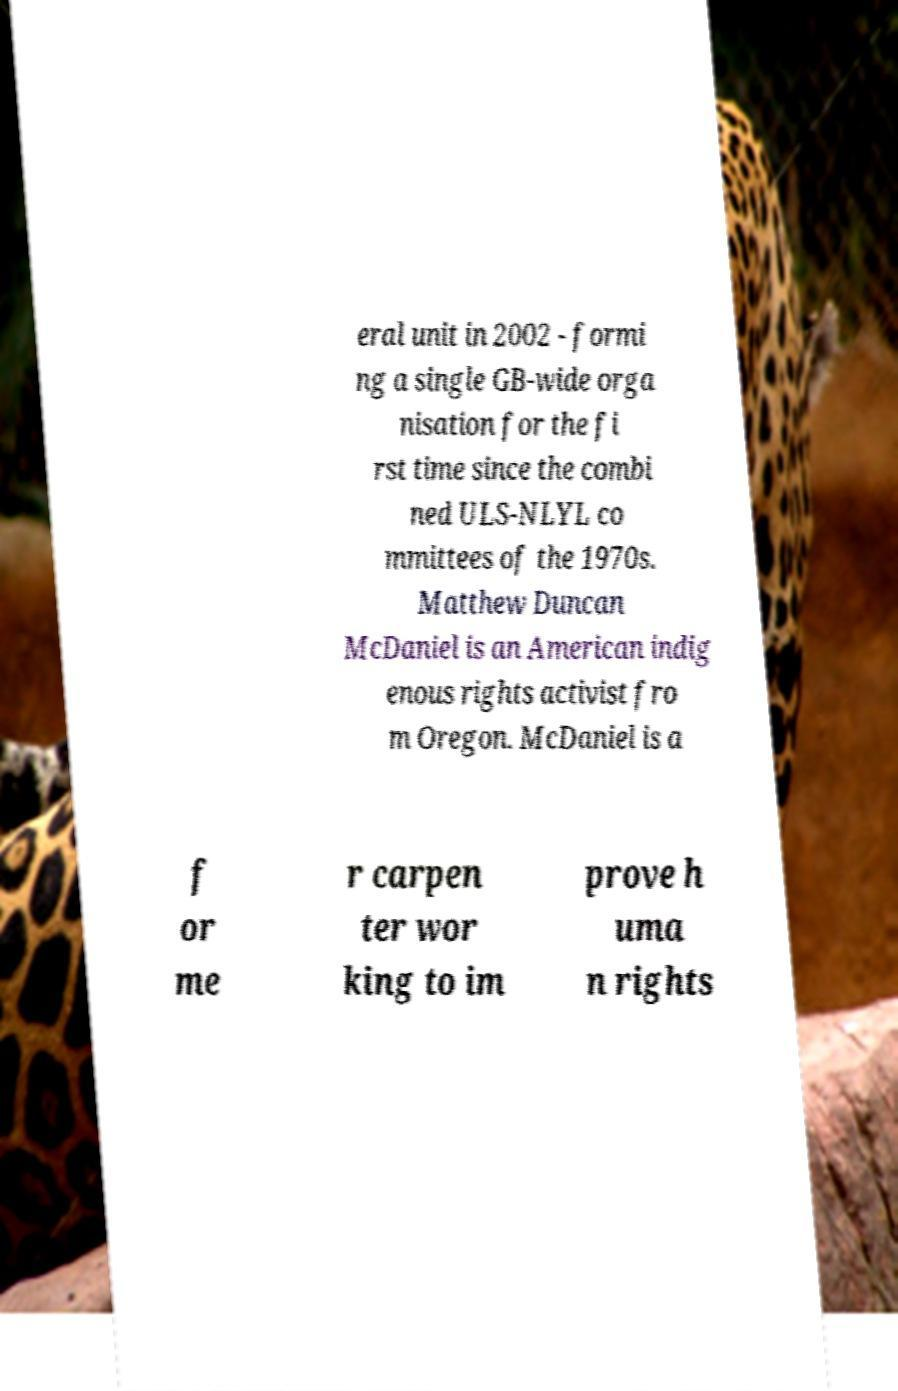Please read and relay the text visible in this image. What does it say? eral unit in 2002 - formi ng a single GB-wide orga nisation for the fi rst time since the combi ned ULS-NLYL co mmittees of the 1970s. Matthew Duncan McDaniel is an American indig enous rights activist fro m Oregon. McDaniel is a f or me r carpen ter wor king to im prove h uma n rights 